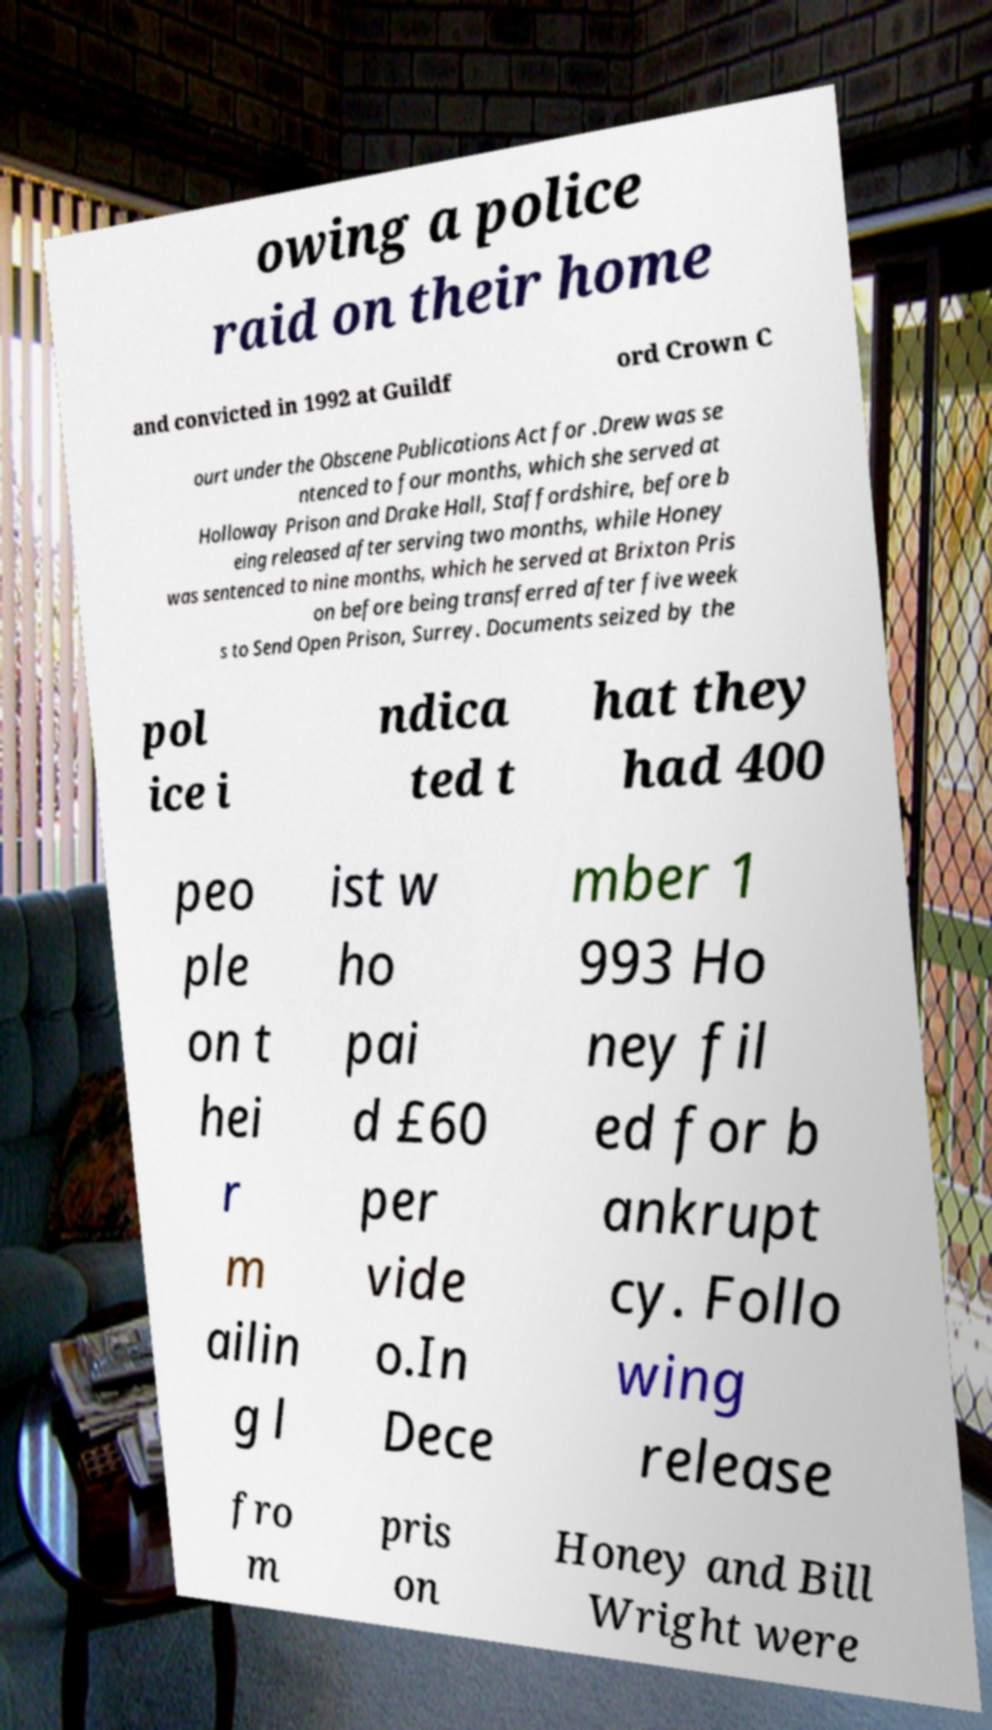Please identify and transcribe the text found in this image. owing a police raid on their home and convicted in 1992 at Guildf ord Crown C ourt under the Obscene Publications Act for .Drew was se ntenced to four months, which she served at Holloway Prison and Drake Hall, Staffordshire, before b eing released after serving two months, while Honey was sentenced to nine months, which he served at Brixton Pris on before being transferred after five week s to Send Open Prison, Surrey. Documents seized by the pol ice i ndica ted t hat they had 400 peo ple on t hei r m ailin g l ist w ho pai d £60 per vide o.In Dece mber 1 993 Ho ney fil ed for b ankrupt cy. Follo wing release fro m pris on Honey and Bill Wright were 